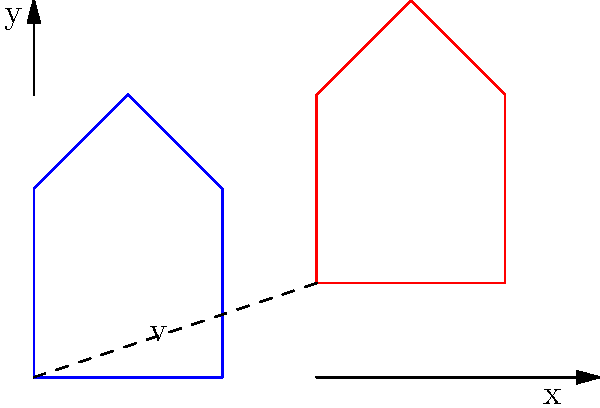Given a complex shape ABCDE in the xy-plane, as shown in blue in the figure, it is translated by a vector $\mathbf{v} = (3, 1)$. The resulting shape after translation is shown in red. If point A of the original shape has coordinates $(0, 0)$, what are the coordinates of point C' (the translated position of point C) after the translation? To find the coordinates of point C' after translation, we need to follow these steps:

1) First, identify the coordinates of point C in the original shape:
   C has coordinates (2, 2)

2) Recall the translation vector:
   $\mathbf{v} = (3, 1)$

3) In a translation, every point of the shape is moved by the same vector. To find the new coordinates, we add the components of the translation vector to the original coordinates:

   New x-coordinate = Original x-coordinate + x-component of translation vector
   New y-coordinate = Original y-coordinate + y-component of translation vector

4) For point C:
   New x-coordinate = 2 + 3 = 5
   New y-coordinate = 2 + 1 = 3

5) Therefore, the coordinates of C' after translation are (5, 3)

This problem demonstrates how translation in geometry can be represented as vector addition, a concept often utilized in computer graphics and image processing algorithms.
Answer: $(5, 3)$ 